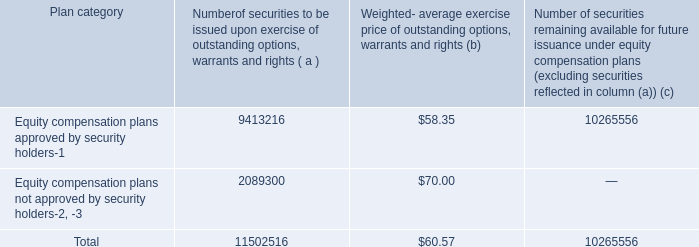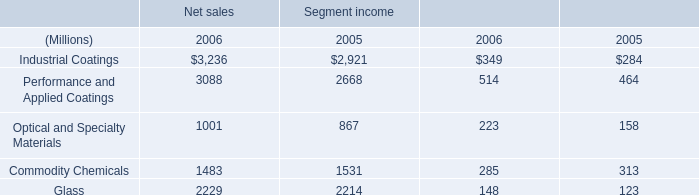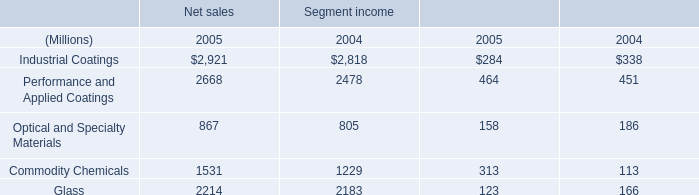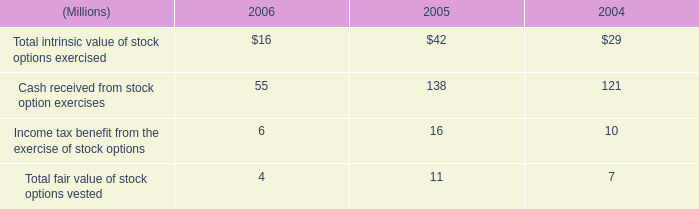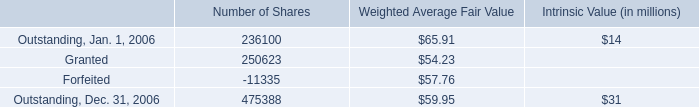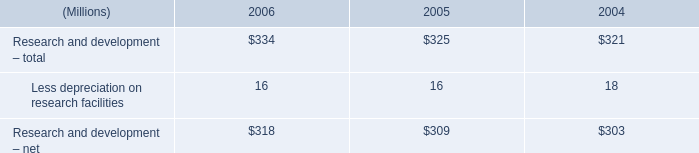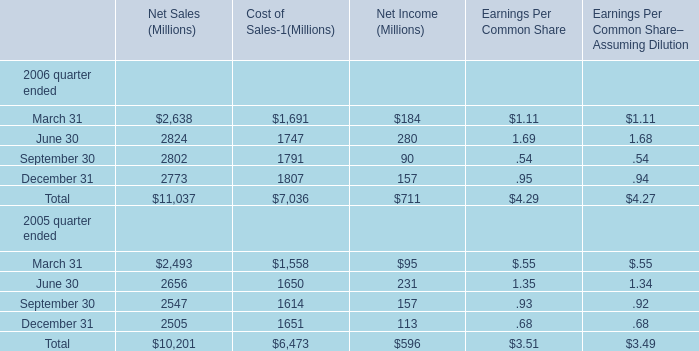what was the percentage change in earnings per share from 2005 to 2006? 
Computations: ((4.27 - 3.49) / 3.49)
Answer: 0.2235. 